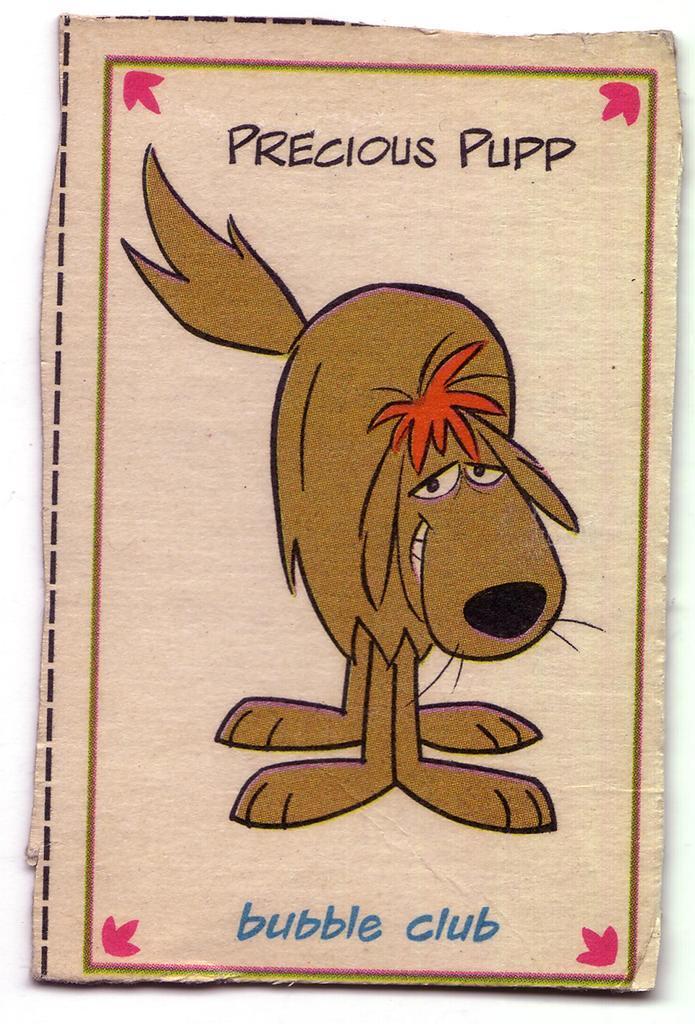Please provide a concise description of this image. In this image we can see a cartoon. 